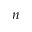Convert formula to latex. <formula><loc_0><loc_0><loc_500><loc_500>n</formula> 